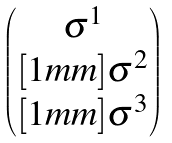Convert formula to latex. <formula><loc_0><loc_0><loc_500><loc_500>\begin{pmatrix} \sigma ^ { 1 } \\ [ 1 m m ] \sigma ^ { 2 } \\ [ 1 m m ] \sigma ^ { 3 } \end{pmatrix}</formula> 